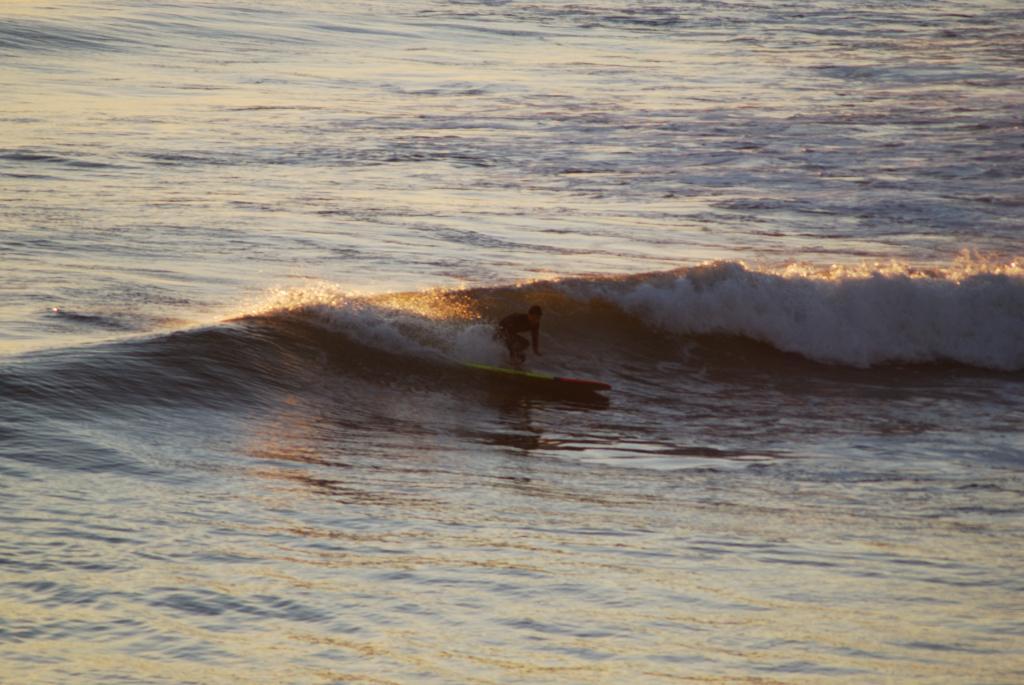Describe this image in one or two sentences. This is the picture of a sea. In this image there is a person surfing with the surfboard on the water. 